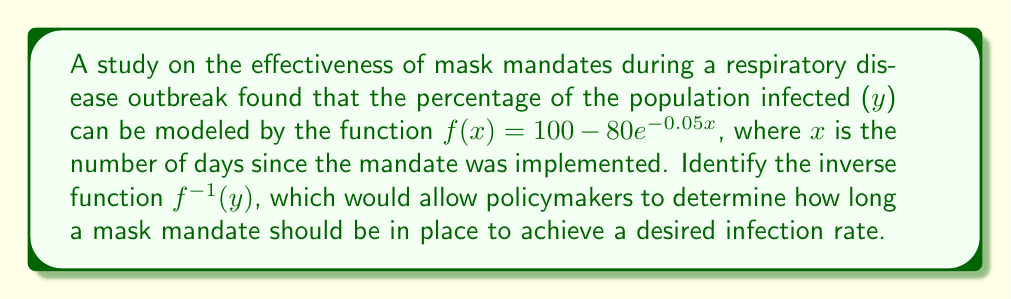Solve this math problem. To find the inverse function, we'll follow these steps:

1) Start with the original function:
   $y = 100 - 80e^{-0.05x}$

2) Swap $x$ and $y$:
   $x = 100 - 80e^{-0.05y}$

3) Subtract 100 from both sides:
   $x - 100 = -80e^{-0.05y}$

4) Divide both sides by -80:
   $\frac{x - 100}{-80} = e^{-0.05y}$

5) Take the natural log of both sides:
   $\ln(\frac{100 - x}{80}) = -0.05y$

6) Divide both sides by -0.05:
   $\frac{\ln(\frac{100 - x}{80})}{-0.05} = y$

7) This is now in the form $y = f^{-1}(x)$, so we can write our final answer:
   $f^{-1}(x) = \frac{\ln(\frac{100 - x}{80})}{-0.05}$

This inverse function allows policymakers to input a desired infection rate ($x$) and determine the number of days ($y$) the mask mandate should be in place to achieve that rate.
Answer: $f^{-1}(x) = \frac{\ln(\frac{100 - x}{80})}{-0.05}$ 